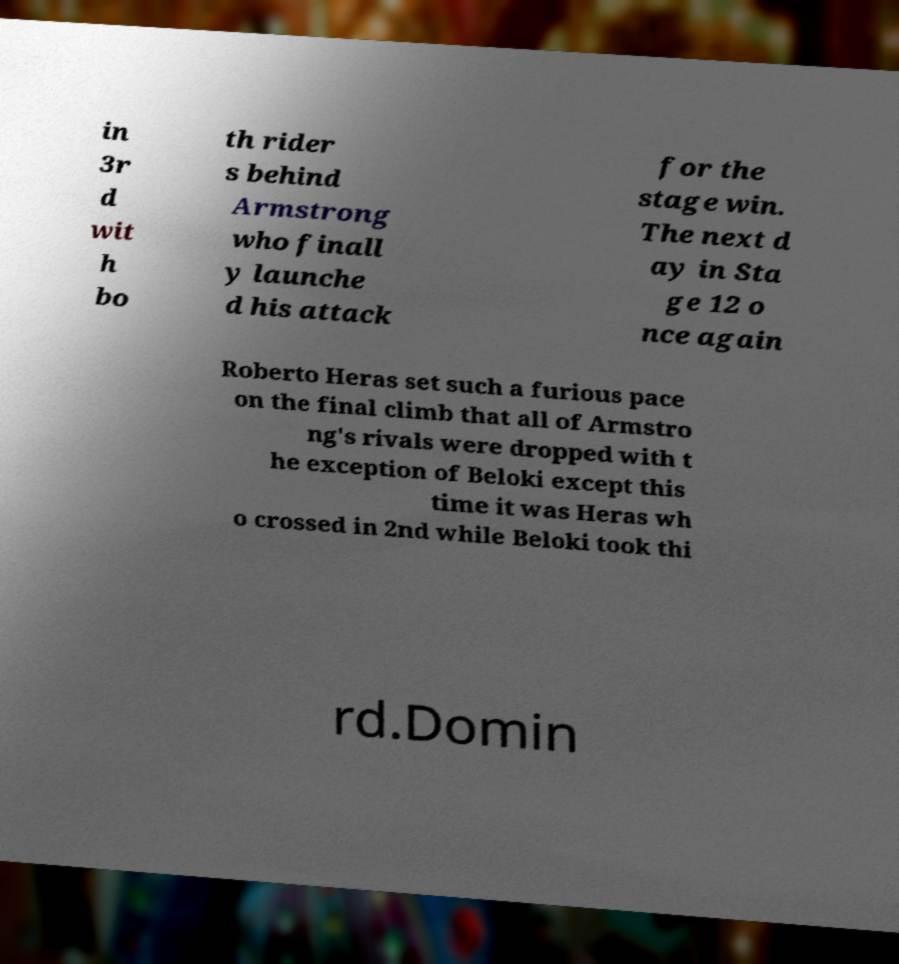There's text embedded in this image that I need extracted. Can you transcribe it verbatim? in 3r d wit h bo th rider s behind Armstrong who finall y launche d his attack for the stage win. The next d ay in Sta ge 12 o nce again Roberto Heras set such a furious pace on the final climb that all of Armstro ng's rivals were dropped with t he exception of Beloki except this time it was Heras wh o crossed in 2nd while Beloki took thi rd.Domin 